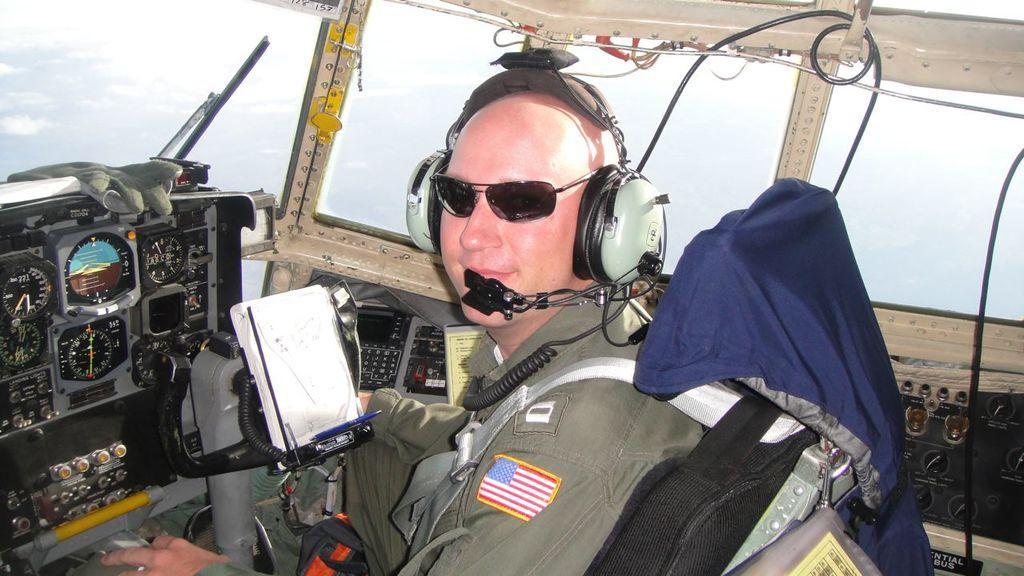How would you summarize this image in a sentence or two? In the foreground of the picture we can see a person sitting in the airplane. In the background we can see sky. 